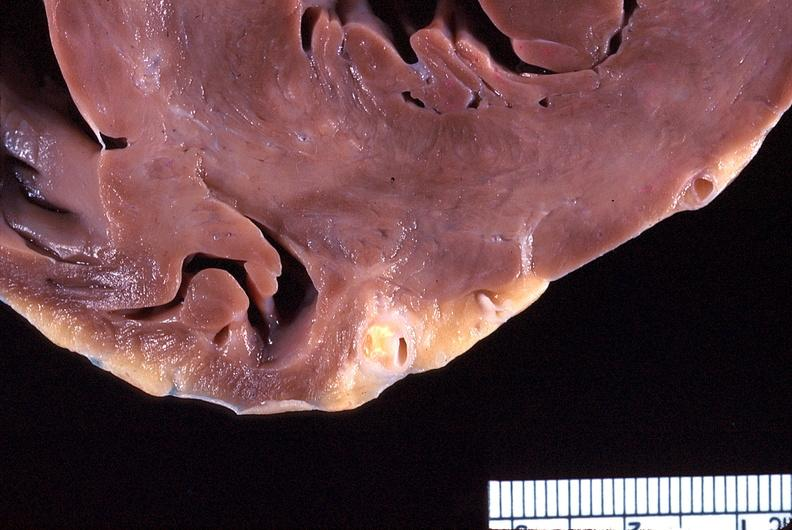s cardiovascular present?
Answer the question using a single word or phrase. Yes 